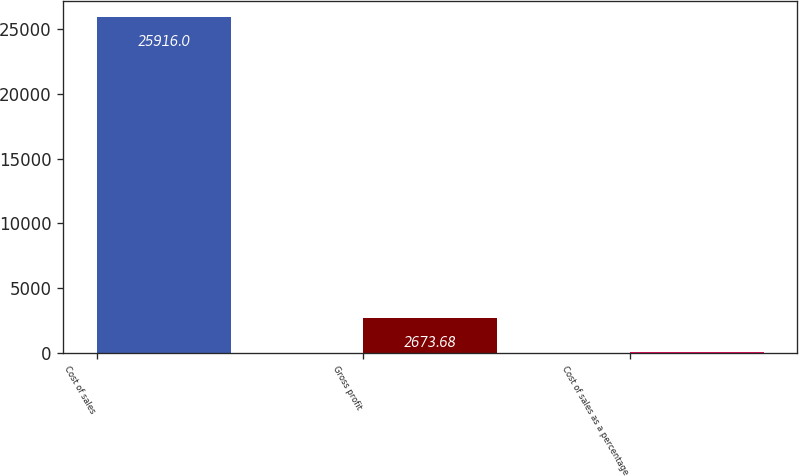Convert chart. <chart><loc_0><loc_0><loc_500><loc_500><bar_chart><fcel>Cost of sales<fcel>Gross profit<fcel>Cost of sales as a percentage<nl><fcel>25916<fcel>2673.68<fcel>91.2<nl></chart> 